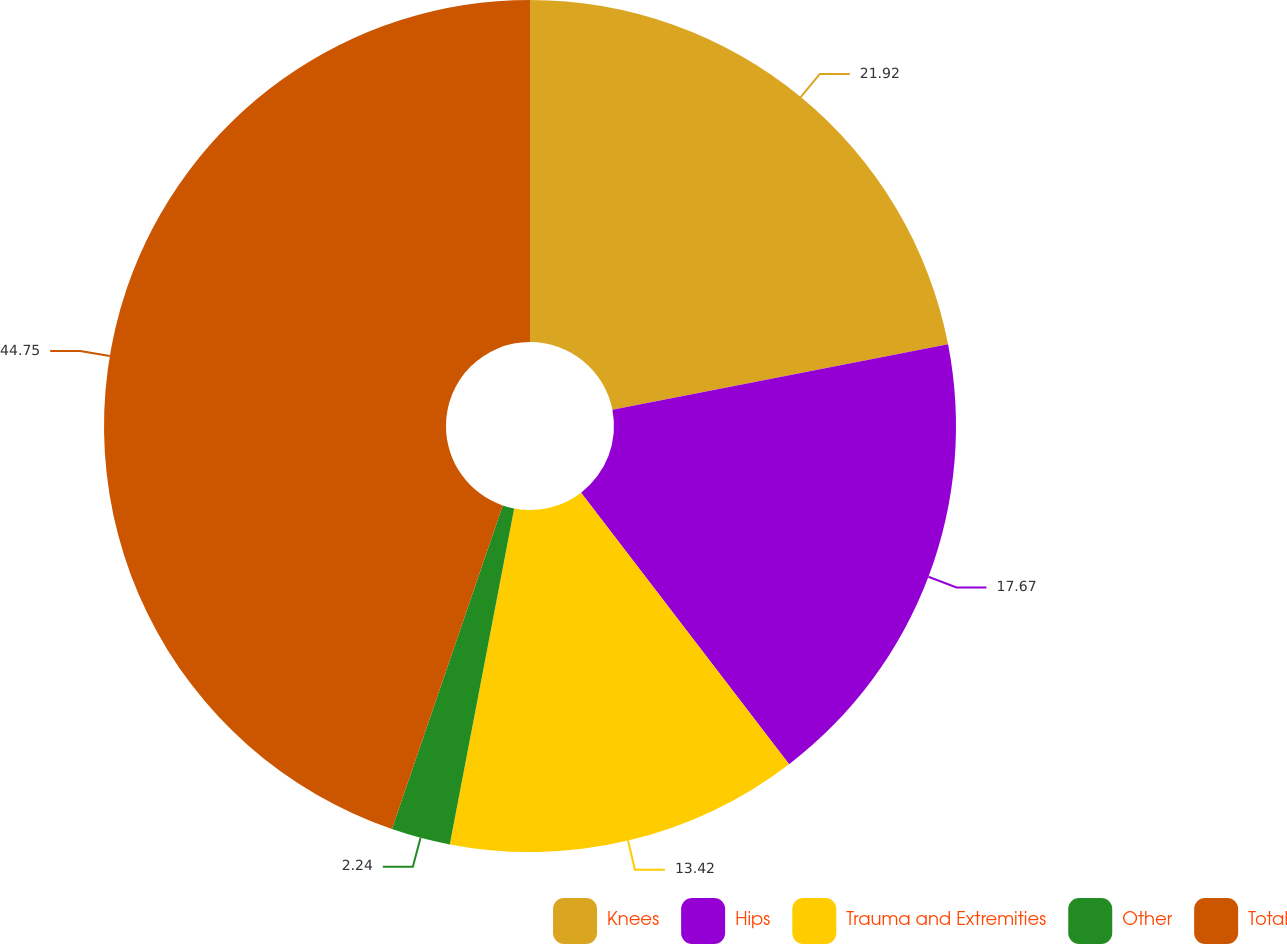Convert chart. <chart><loc_0><loc_0><loc_500><loc_500><pie_chart><fcel>Knees<fcel>Hips<fcel>Trauma and Extremities<fcel>Other<fcel>Total<nl><fcel>21.92%<fcel>17.67%<fcel>13.42%<fcel>2.24%<fcel>44.74%<nl></chart> 